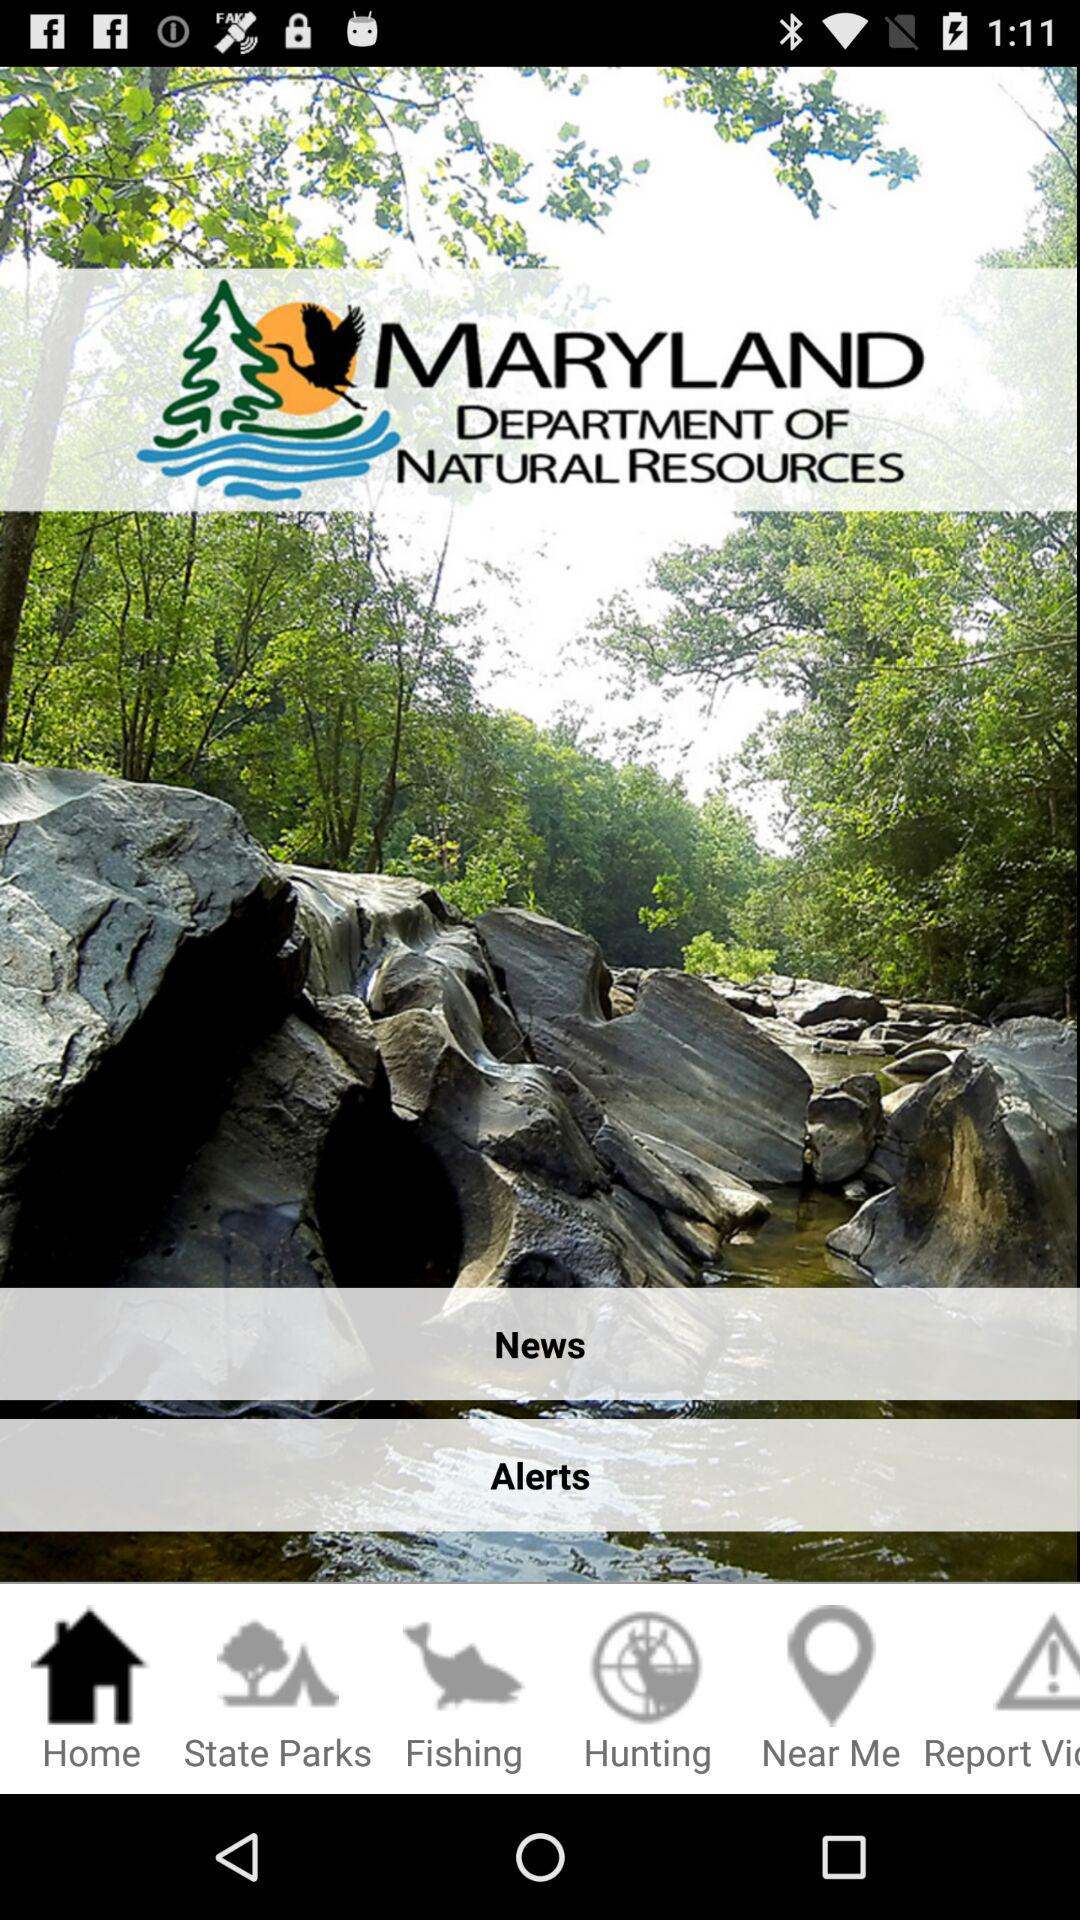Which tab has been selected? The tab "Home" has been selected. 